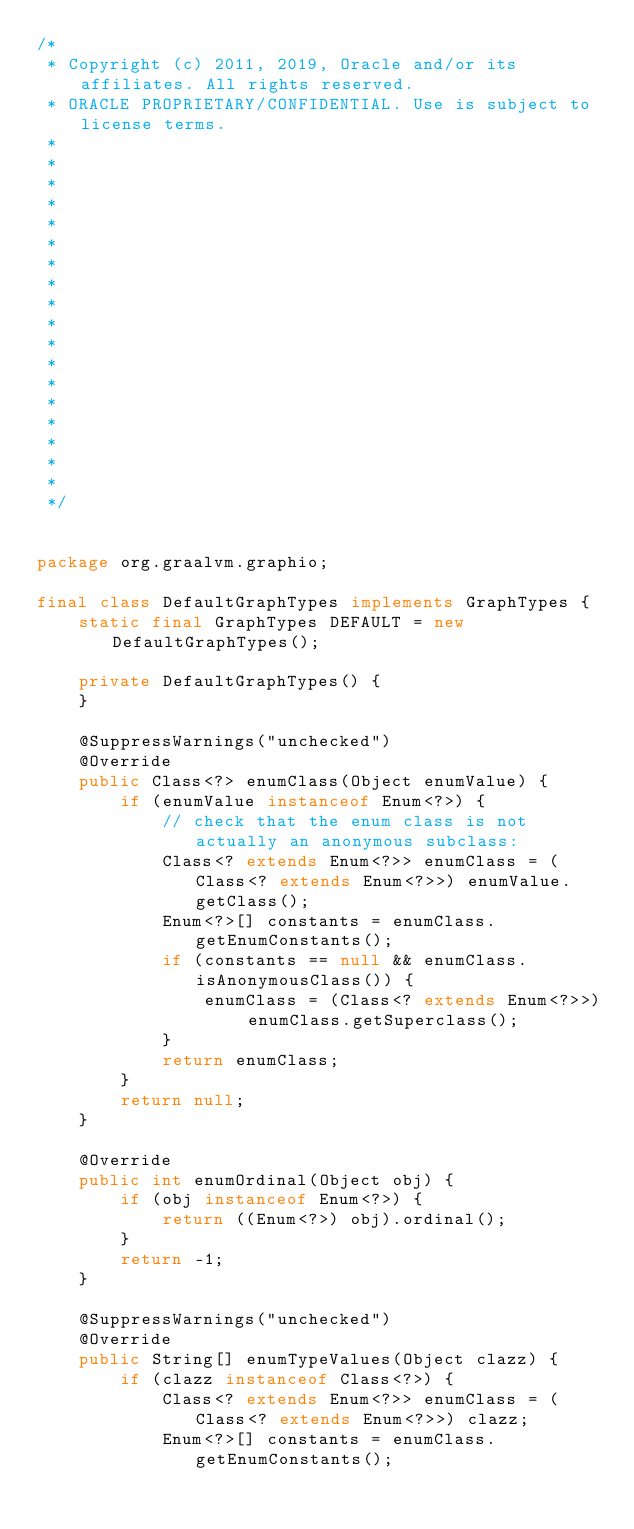Convert code to text. <code><loc_0><loc_0><loc_500><loc_500><_Java_>/*
 * Copyright (c) 2011, 2019, Oracle and/or its affiliates. All rights reserved.
 * ORACLE PROPRIETARY/CONFIDENTIAL. Use is subject to license terms.
 *
 *
 *
 *
 *
 *
 *
 *
 *
 *
 *
 *
 *
 *
 *
 *
 *
 *
 */


package org.graalvm.graphio;

final class DefaultGraphTypes implements GraphTypes {
    static final GraphTypes DEFAULT = new DefaultGraphTypes();

    private DefaultGraphTypes() {
    }

    @SuppressWarnings("unchecked")
    @Override
    public Class<?> enumClass(Object enumValue) {
        if (enumValue instanceof Enum<?>) {
            // check that the enum class is not actually an anonymous subclass:
            Class<? extends Enum<?>> enumClass = (Class<? extends Enum<?>>) enumValue.getClass();
            Enum<?>[] constants = enumClass.getEnumConstants();
            if (constants == null && enumClass.isAnonymousClass()) {
                enumClass = (Class<? extends Enum<?>>) enumClass.getSuperclass();
            }
            return enumClass;
        }
        return null;
    }

    @Override
    public int enumOrdinal(Object obj) {
        if (obj instanceof Enum<?>) {
            return ((Enum<?>) obj).ordinal();
        }
        return -1;
    }

    @SuppressWarnings("unchecked")
    @Override
    public String[] enumTypeValues(Object clazz) {
        if (clazz instanceof Class<?>) {
            Class<? extends Enum<?>> enumClass = (Class<? extends Enum<?>>) clazz;
            Enum<?>[] constants = enumClass.getEnumConstants();</code> 